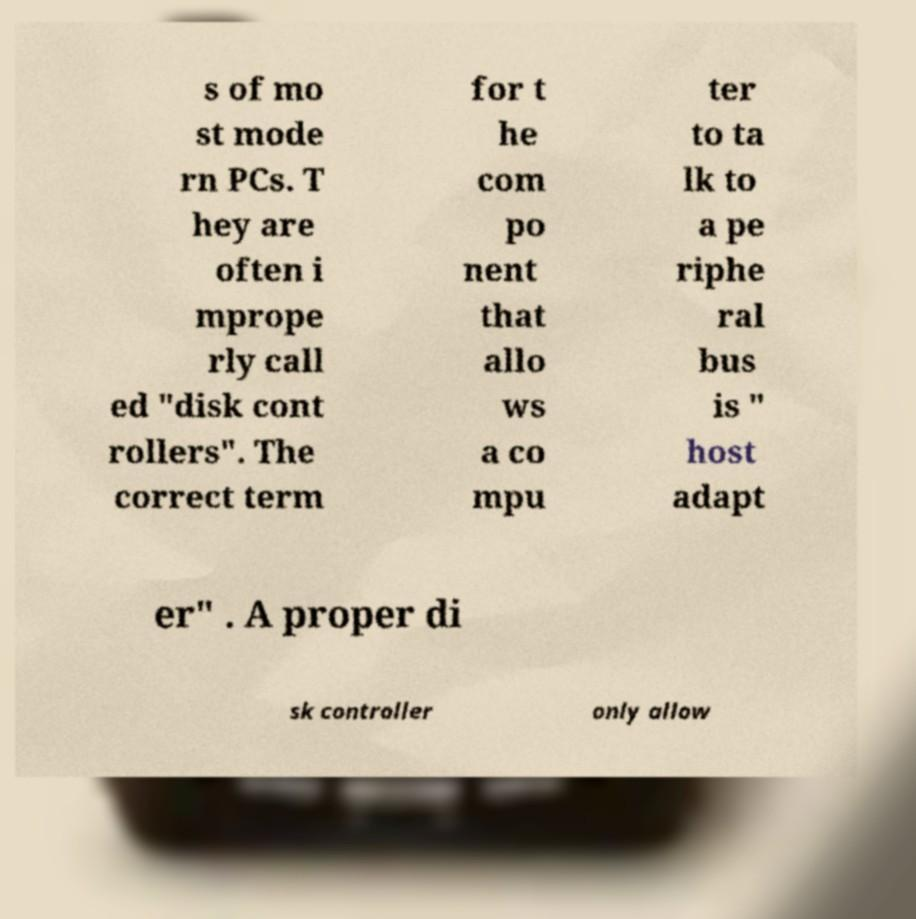For documentation purposes, I need the text within this image transcribed. Could you provide that? s of mo st mode rn PCs. T hey are often i mprope rly call ed "disk cont rollers". The correct term for t he com po nent that allo ws a co mpu ter to ta lk to a pe riphe ral bus is " host adapt er" . A proper di sk controller only allow 